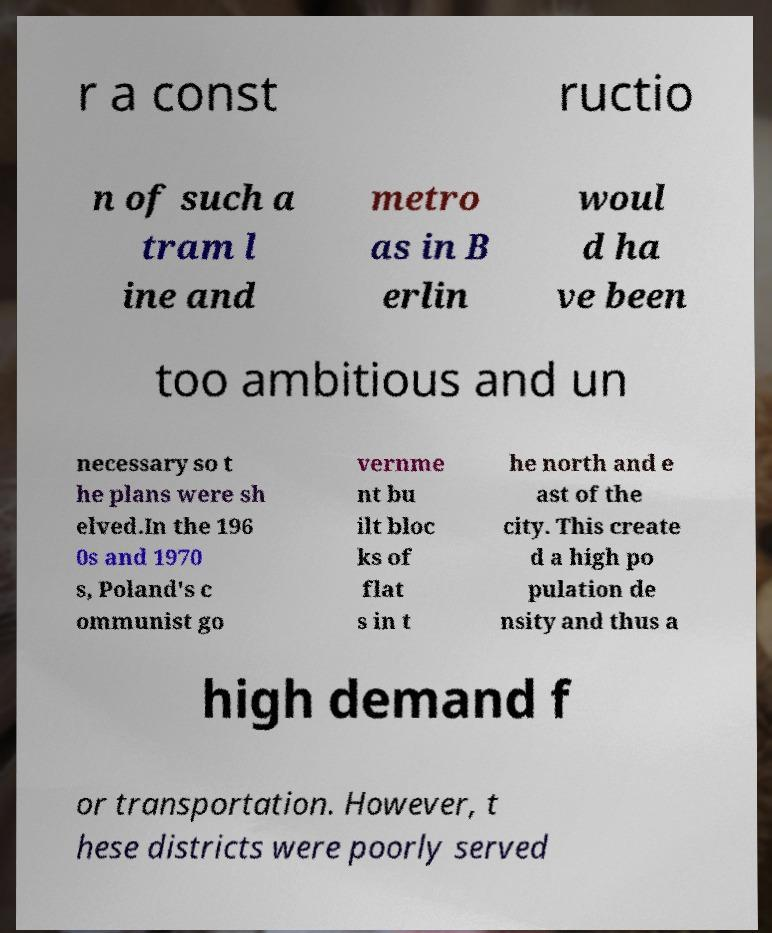Can you read and provide the text displayed in the image?This photo seems to have some interesting text. Can you extract and type it out for me? r a const ructio n of such a tram l ine and metro as in B erlin woul d ha ve been too ambitious and un necessary so t he plans were sh elved.In the 196 0s and 1970 s, Poland's c ommunist go vernme nt bu ilt bloc ks of flat s in t he north and e ast of the city. This create d a high po pulation de nsity and thus a high demand f or transportation. However, t hese districts were poorly served 